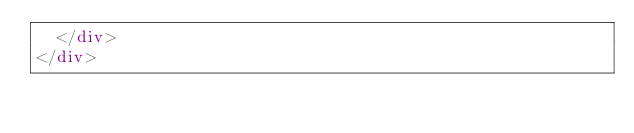<code> <loc_0><loc_0><loc_500><loc_500><_HTML_>  </div>
</div>
</code> 